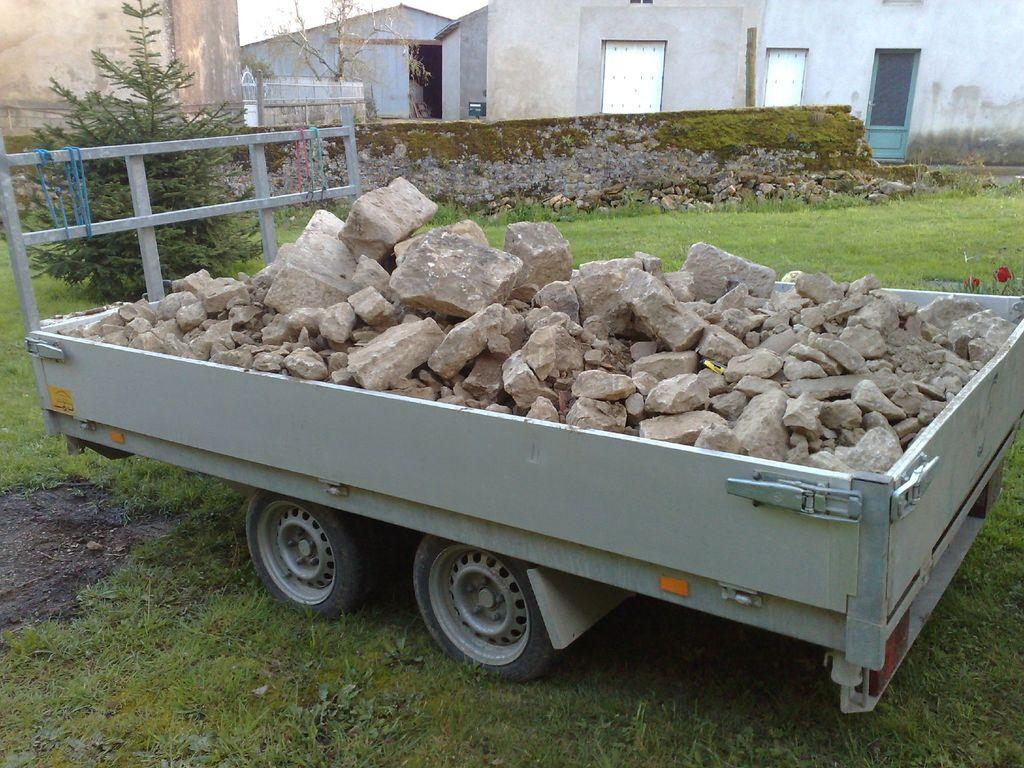What is the main object in the image? There is a cart in the image. Where is the cart located? The cart is on the grass. What is on the cart? There are stones on the cart. What can be seen in the background of the image? There are trees, buildings, and a wall in the background of the image. What type of advertisement can be seen on the cart in the image? There is no advertisement present on the cart in the image. Can you describe the smile of the person pushing the cart in the image? There is no person pushing the cart in the image, so it is not possible to describe their smile. 